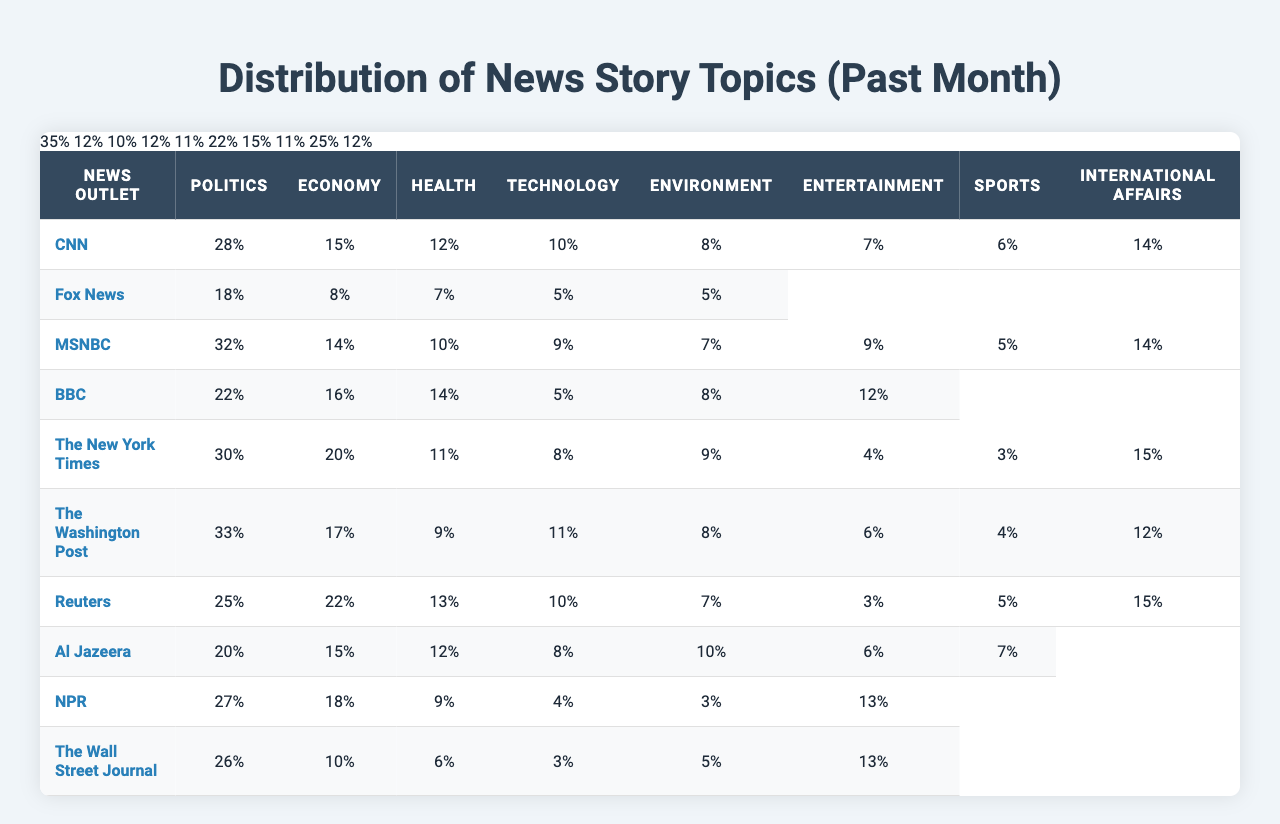What news outlet covered the highest percentage of Politics stories? By examining the Politics column in the table, CNN has reported 28%, which is the highest compared to other outlets.
Answer: CNN Which news outlet had the least coverage of Health stories? Looking at the Health column, Fox News has the lowest percentage at 8%.
Answer: Fox News Calculate the average number of Economy stories covered by the news outlets. To find the average, sum the Economy values (15 + 18 + 14 + 16 + 20 + 17 + 22 + 15 + 18 + 25 =  190) and divide by the number of outlets which is 10. Thus, 190/10 = 19.
Answer: 19 Did any news outlet cover more than 30% of Entertainment stories? Upon reviewing the Entertainment column, we see that the most covered outlet is CNN with 7%, which is not more than 30%.
Answer: No Which topic had the highest total coverage across all news outlets? When summing up each topic, Politics accounts for 28 + 35 + 32 + 22 + 30 + 33 + 25 + 20 + 27 + 26 =  258, Environment has 8 + 5 + 7 + 11 + 9 + 8 + 7 + 10 + 11 + 6 =  82, and so on. Politics has the maximum total of 258, making it the highest.
Answer: Politics What is the difference in the percentage of Sports stories covered by Fox News and Al Jazeera? Fox News covers 10% of Sports stories while Al Jazeera covers 7%. The difference is 10 - 7 = 3%.
Answer: 3% Has The Washington Post covered more Health stories than NPR? Comparing the Health values, The Washington Post has 9% while NPR stands at 15%, indicating that NPR has more.
Answer: No Which two news outlets covered the most International Affairs stories? By reviewing the International Affairs column, both NPR and Al Jazeera have the highest at 22% and 15% respectively, thus making a total of 22% for NPR and 15% for Al Jazeera.
Answer: NPR and Al Jazeera What percentage of total coverage does Entertainment represent across all news outlets? The total for Entertainment is 7 + 12 + 9 + 5 + 4 + 6 + 3 + 6 + 4 + 3 =  59%. Since there are 10 outlets, the average is 59%/10 = 5.9%.
Answer: 5.9% 